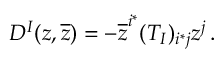<formula> <loc_0><loc_0><loc_500><loc_500>D ^ { I } ( z , \overline { z } ) = - \overline { z } ^ { i ^ { * } } ( T _ { I } ) _ { i ^ { * } j } z ^ { j } \, .</formula> 